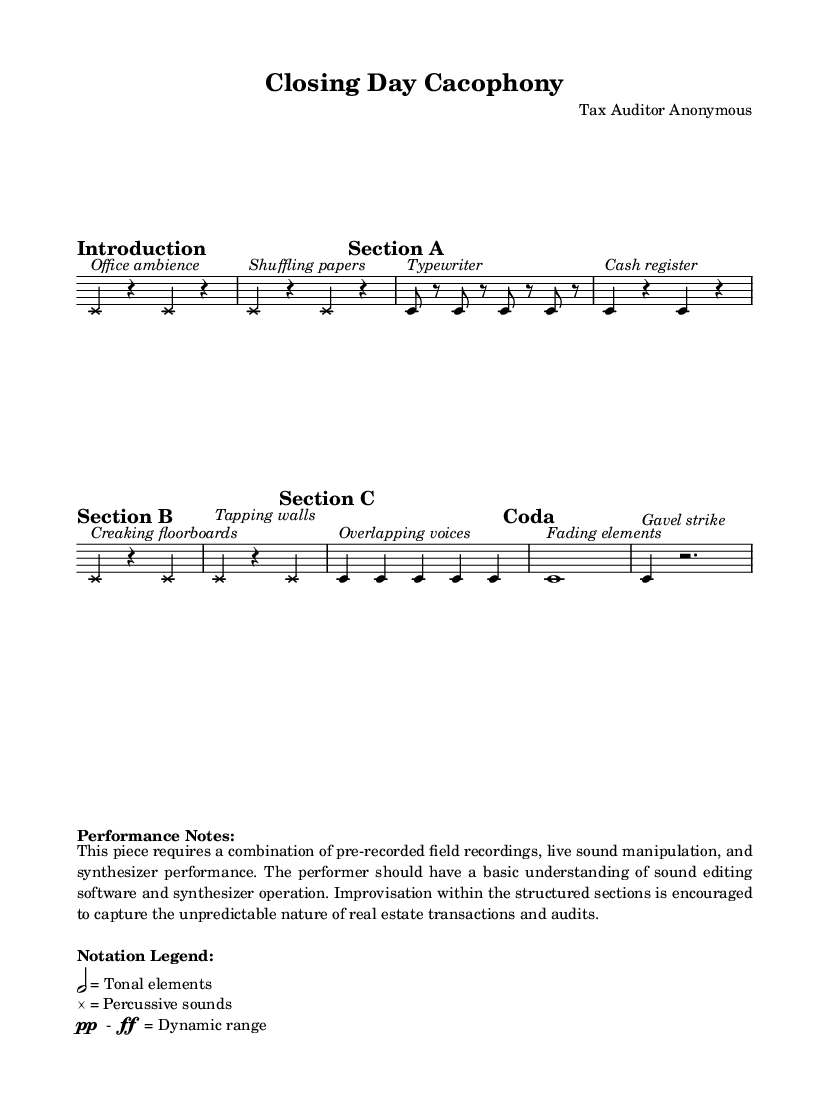What is the time signature of Section B? The time signature of Section B is 3/4, as indicated in the section marking.
Answer: 3/4 What dynamic range is suggested for the piece? The dynamic range is indicated by the symbols 'pp' (pianissimo) and 'ff' (fortissimo), suggesting soft and loud dynamics throughout the piece.
Answer: pp - ff What type of recordings are primarily used in this piece? The piece primarily uses field recordings, as suggested by the performance notes that emphasize pre-recorded sounds from real estate transactions and property inspections.
Answer: Field recordings How many sections are there in the piece? The piece is divided into four distinct sections: Introduction, Section A, Section B, Section C, and a Coda, totaling five sections.
Answer: Five sections What is the primary sound in the Coda? The primary sound in the Coda is described as a "Gavel strike," which indicates a significant auditory cue associated with real estate transactions.
Answer: Gavel strike In which section are overlapping voices introduced? Overlapping voices are introduced in Section C, as indicated by the specific sound description noted in that section.
Answer: Section C 